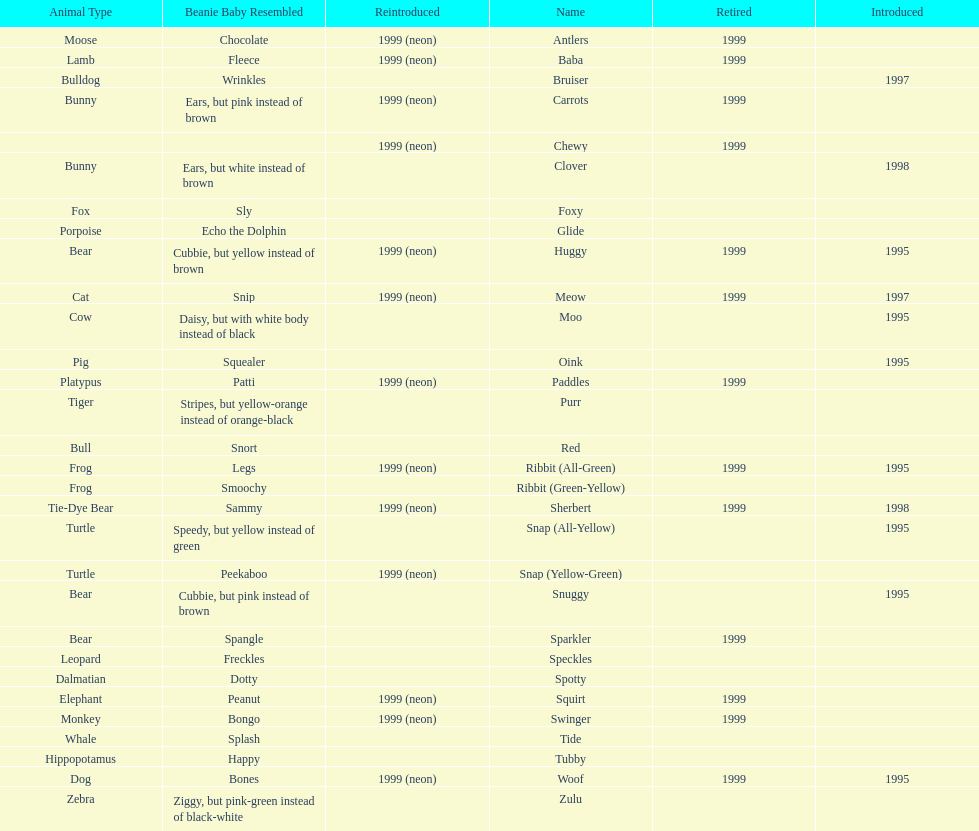What is the name of the pillow pal listed after clover? Foxy. 